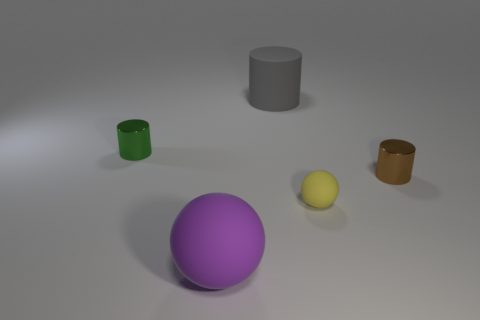Are there any tiny cylinders that are left of the cylinder to the right of the yellow ball?
Your answer should be compact. Yes. There is a big object in front of the small green metallic cylinder; what is it made of?
Offer a terse response. Rubber. Does the large gray rubber object have the same shape as the yellow matte thing?
Provide a succinct answer. No. What is the color of the big thing that is to the right of the big rubber thing that is in front of the cylinder left of the large purple rubber thing?
Give a very brief answer. Gray. How many large blue matte objects have the same shape as the brown shiny thing?
Offer a terse response. 0. What size is the shiny cylinder that is on the left side of the small object on the right side of the small yellow sphere?
Make the answer very short. Small. Do the brown metal cylinder and the green shiny object have the same size?
Your answer should be very brief. Yes. Is there a metal object that is behind the metallic object in front of the tiny metallic thing to the left of the gray matte object?
Your answer should be very brief. Yes. What is the size of the green thing?
Keep it short and to the point. Small. How many shiny objects are the same size as the green cylinder?
Provide a succinct answer. 1. 